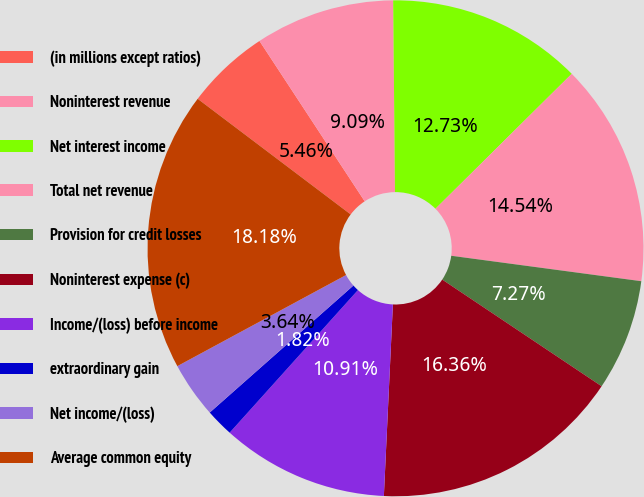Convert chart to OTSL. <chart><loc_0><loc_0><loc_500><loc_500><pie_chart><fcel>(in millions except ratios)<fcel>Noninterest revenue<fcel>Net interest income<fcel>Total net revenue<fcel>Provision for credit losses<fcel>Noninterest expense (c)<fcel>Income/(loss) before income<fcel>extraordinary gain<fcel>Net income/(loss)<fcel>Average common equity<nl><fcel>5.46%<fcel>9.09%<fcel>12.73%<fcel>14.54%<fcel>7.27%<fcel>16.36%<fcel>10.91%<fcel>1.82%<fcel>3.64%<fcel>18.18%<nl></chart> 